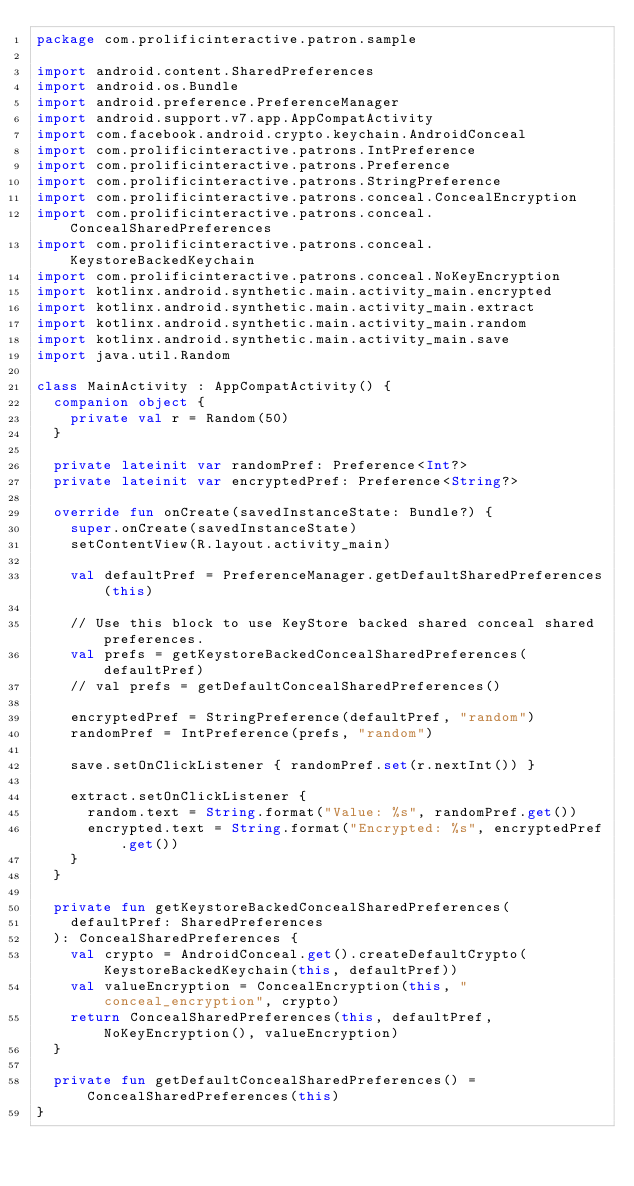<code> <loc_0><loc_0><loc_500><loc_500><_Kotlin_>package com.prolificinteractive.patron.sample

import android.content.SharedPreferences
import android.os.Bundle
import android.preference.PreferenceManager
import android.support.v7.app.AppCompatActivity
import com.facebook.android.crypto.keychain.AndroidConceal
import com.prolificinteractive.patrons.IntPreference
import com.prolificinteractive.patrons.Preference
import com.prolificinteractive.patrons.StringPreference
import com.prolificinteractive.patrons.conceal.ConcealEncryption
import com.prolificinteractive.patrons.conceal.ConcealSharedPreferences
import com.prolificinteractive.patrons.conceal.KeystoreBackedKeychain
import com.prolificinteractive.patrons.conceal.NoKeyEncryption
import kotlinx.android.synthetic.main.activity_main.encrypted
import kotlinx.android.synthetic.main.activity_main.extract
import kotlinx.android.synthetic.main.activity_main.random
import kotlinx.android.synthetic.main.activity_main.save
import java.util.Random

class MainActivity : AppCompatActivity() {
  companion object {
    private val r = Random(50)
  }

  private lateinit var randomPref: Preference<Int?>
  private lateinit var encryptedPref: Preference<String?>

  override fun onCreate(savedInstanceState: Bundle?) {
    super.onCreate(savedInstanceState)
    setContentView(R.layout.activity_main)

    val defaultPref = PreferenceManager.getDefaultSharedPreferences(this)

    // Use this block to use KeyStore backed shared conceal shared preferences.
    val prefs = getKeystoreBackedConcealSharedPreferences(defaultPref)
    // val prefs = getDefaultConcealSharedPreferences()

    encryptedPref = StringPreference(defaultPref, "random")
    randomPref = IntPreference(prefs, "random")

    save.setOnClickListener { randomPref.set(r.nextInt()) }

    extract.setOnClickListener {
      random.text = String.format("Value: %s", randomPref.get())
      encrypted.text = String.format("Encrypted: %s", encryptedPref.get())
    }
  }

  private fun getKeystoreBackedConcealSharedPreferences(
    defaultPref: SharedPreferences
  ): ConcealSharedPreferences {
    val crypto = AndroidConceal.get().createDefaultCrypto(KeystoreBackedKeychain(this, defaultPref))
    val valueEncryption = ConcealEncryption(this, "conceal_encryption", crypto)
    return ConcealSharedPreferences(this, defaultPref, NoKeyEncryption(), valueEncryption)
  }

  private fun getDefaultConcealSharedPreferences() = ConcealSharedPreferences(this)
}
</code> 